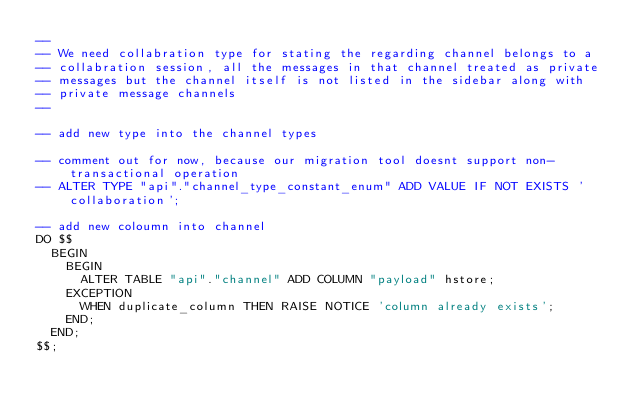<code> <loc_0><loc_0><loc_500><loc_500><_SQL_>--
-- We need collabration type for stating the regarding channel belongs to a
-- collabration session, all the messages in that channel treated as private
-- messages but the channel itself is not listed in the sidebar along with
-- private message channels
--

-- add new type into the channel types

-- comment out for now, because our migration tool doesnt support non-transactional operation
-- ALTER TYPE "api"."channel_type_constant_enum" ADD VALUE IF NOT EXISTS 'collaboration';

-- add new coloumn into channel
DO $$
  BEGIN
    BEGIN
      ALTER TABLE "api"."channel" ADD COLUMN "payload" hstore;
    EXCEPTION
      WHEN duplicate_column THEN RAISE NOTICE 'column already exists';
    END;
  END;
$$;
</code> 